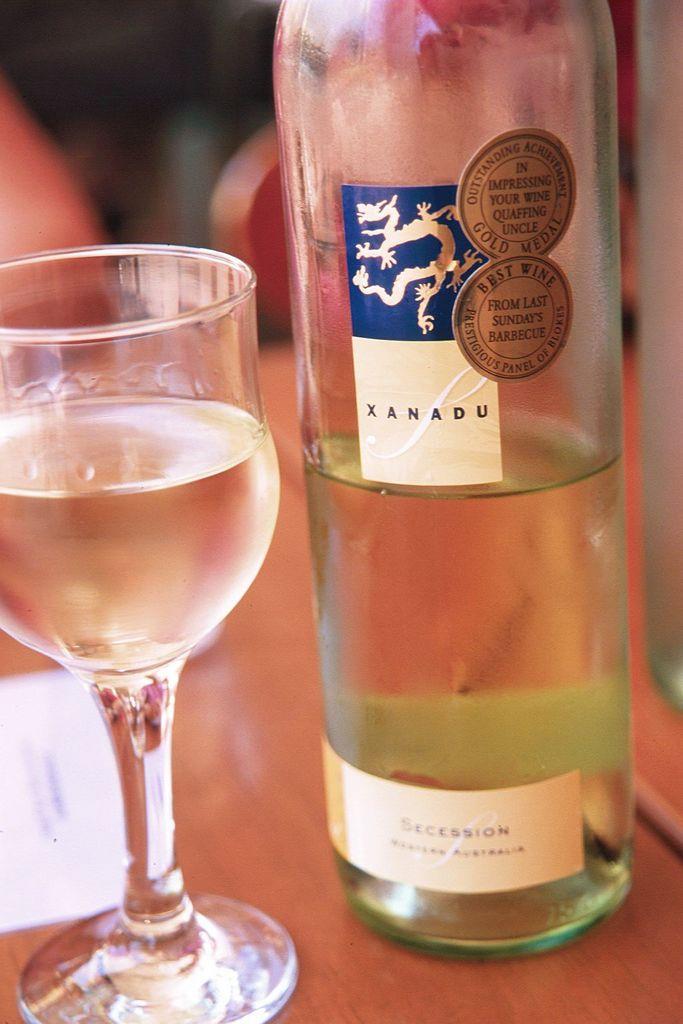In one or two sentences, can you explain what this image depicts? In this image I can see the bottle, glass and few objects on the brown color surface. Background is blurred. 